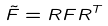Convert formula to latex. <formula><loc_0><loc_0><loc_500><loc_500>\tilde { F } = R F R ^ { T }</formula> 